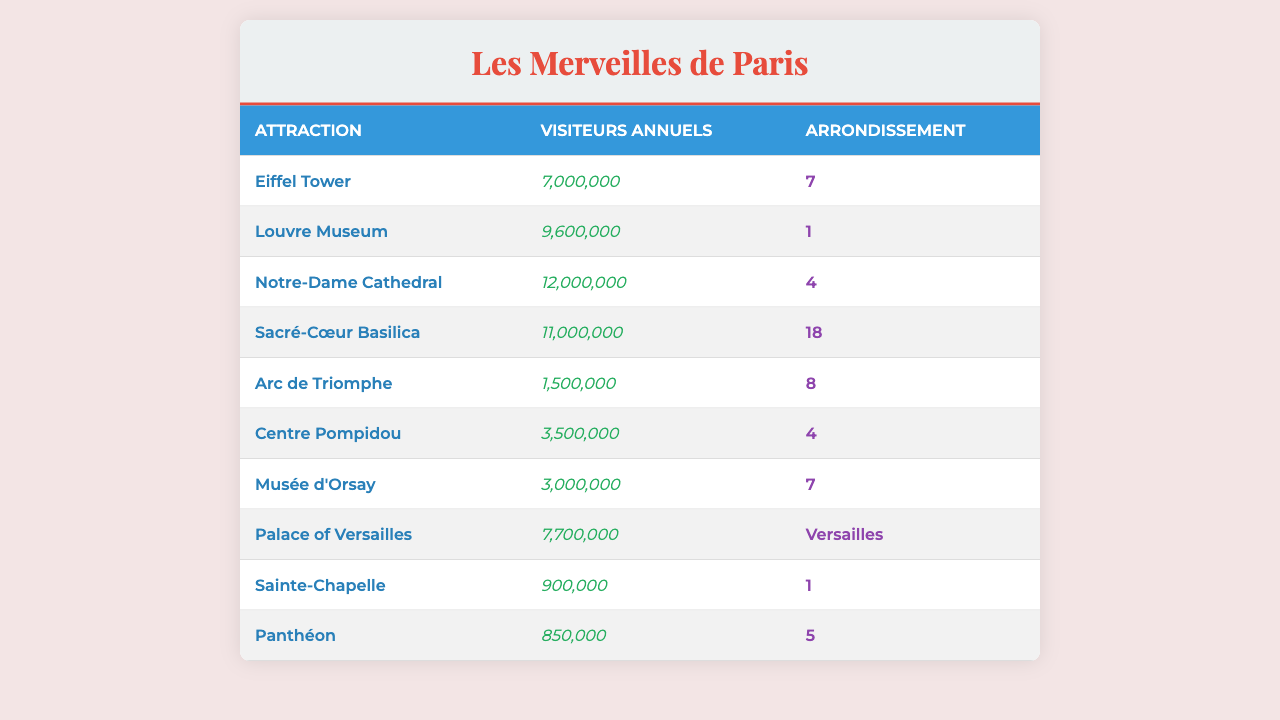What is the annual visitor number for the Eiffel Tower? The table lists the annual visitors for the Eiffel Tower as 7,000,000.
Answer: 7,000,000 Which attraction has the highest annual visitor count? By examining the annual visitors for each attraction, Notre-Dame Cathedral has the highest number at 12,000,000.
Answer: Notre-Dame Cathedral How many visitors does the Louvre Museum attract each year? The table indicates that the Louvre Museum attracts 9,600,000 visitors annually.
Answer: 9,600,000 Which arrondissement has the most attractions listed in the table? Both arrondissement 1 and 4 have two attractions each (Louvre Museum and Sainte-Chapelle in arrondissement 1, and Notre-Dame Cathedral and Centre Pompidou in arrondissement 4). Arrondissement 1 and 4 are tied for the most attractions.
Answer: Arrondissement 1 and 4 What is the sum of annual visitors for both Sacré-Cœur Basilica and Arc de Triomphe? The annual visitors for Sacré-Cœur Basilica are 11,000,000 and for Arc de Triomphe are 1,500,000. Summing these gives 11,000,000 + 1,500,000 = 12,500,000.
Answer: 12,500,000 Is the number of annual visitors to Musée d'Orsay greater than 4 million? The table shows that the annual visitors to Musée d'Orsay amount to 3,000,000, which is less than 4 million.
Answer: No What is the average number of annual visitors for attractions located in arrondissement 7? The attractions in arrondissement 7 are the Eiffel Tower and Musée d'Orsay, with annual visitors of 7,000,000 and 3,000,000 respectively. The average is (7,000,000 + 3,000,000) / 2 = 5,000,000.
Answer: 5,000,000 Which attraction has the least number of annual visitors? The table indicates that Sainte-Chapelle has the least number of annual visitors with 900,000.
Answer: Sainte-Chapelle If you add the annual visitors to the Palace of Versailles and the annual visitors to the Eiffel Tower, how many visitors do you get? The annual visitors to the Palace of Versailles are 7,700,000, and the Eiffel Tower has 7,000,000. Adding these gives 7,700,000 + 7,000,000 = 14,700,000.
Answer: 14,700,000 How many more visitors does Notre-Dame Cathedral receive compared to Panthéon? Notre-Dame Cathedral receives 12,000,000 visitors and Panthéon receives 850,000 visitors. The difference is 12,000,000 - 850,000 = 11,150,000.
Answer: 11,150,000 